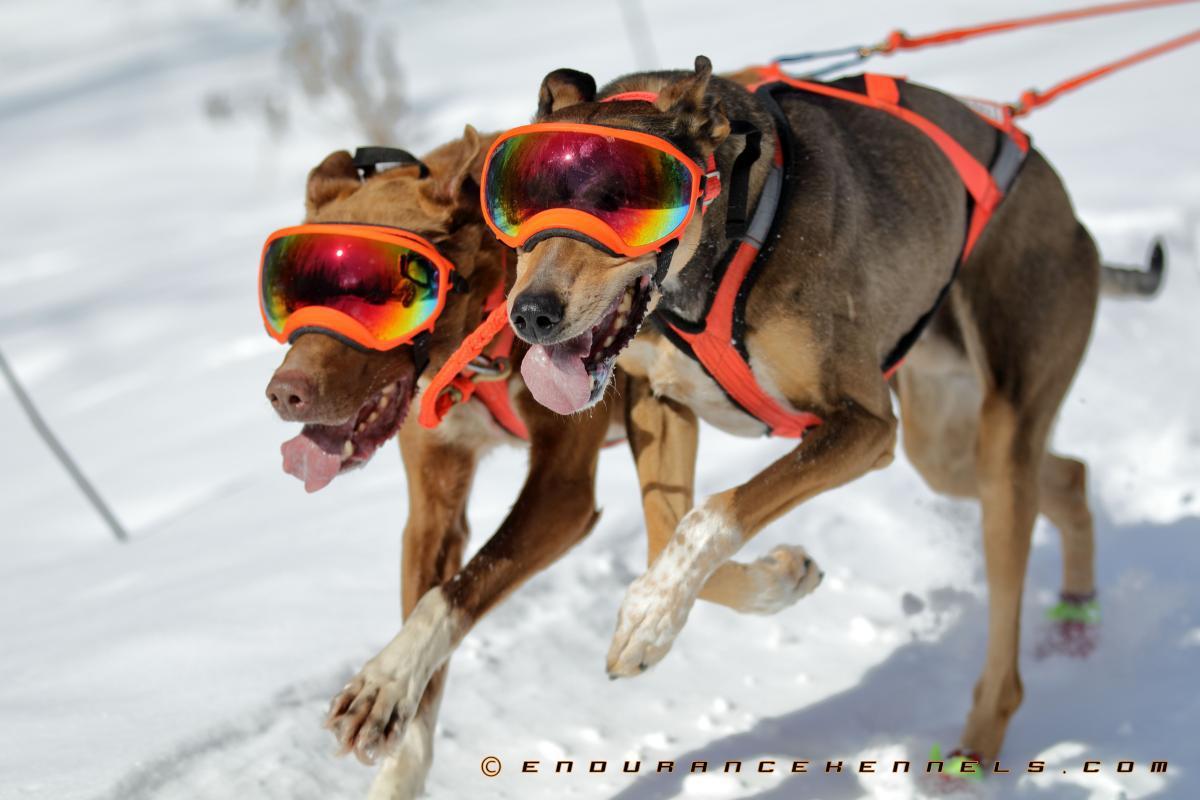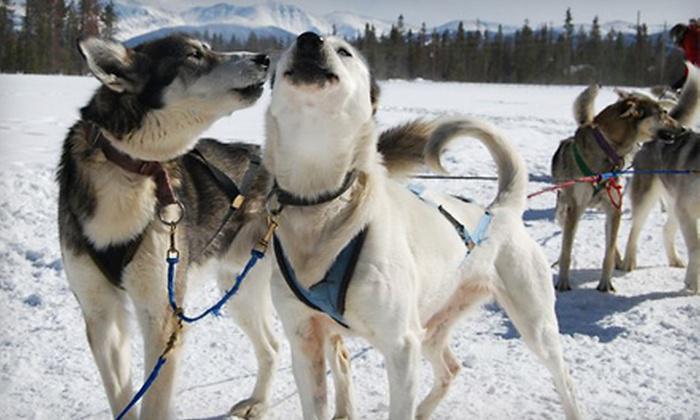The first image is the image on the left, the second image is the image on the right. For the images displayed, is the sentence "In one image, a team of dogs is pulling a sled on which a person is standing, while a second image shows a team of dogs up close, standing in their harnesses." factually correct? Answer yes or no. No. The first image is the image on the left, the second image is the image on the right. Evaluate the accuracy of this statement regarding the images: "None of the harnessed dogs in one image are typical husky-type sled dogs.". Is it true? Answer yes or no. Yes. 